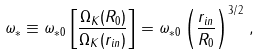<formula> <loc_0><loc_0><loc_500><loc_500>\omega _ { \ast } \equiv \omega _ { \ast 0 } \left [ \frac { \Omega _ { K } ( R _ { 0 } ) } { \Omega _ { K } ( r _ { i n } ) } \right ] = \omega _ { \ast 0 } \left ( \frac { r _ { i n } } { R _ { 0 } } \right ) ^ { 3 / 2 } \, ,</formula> 